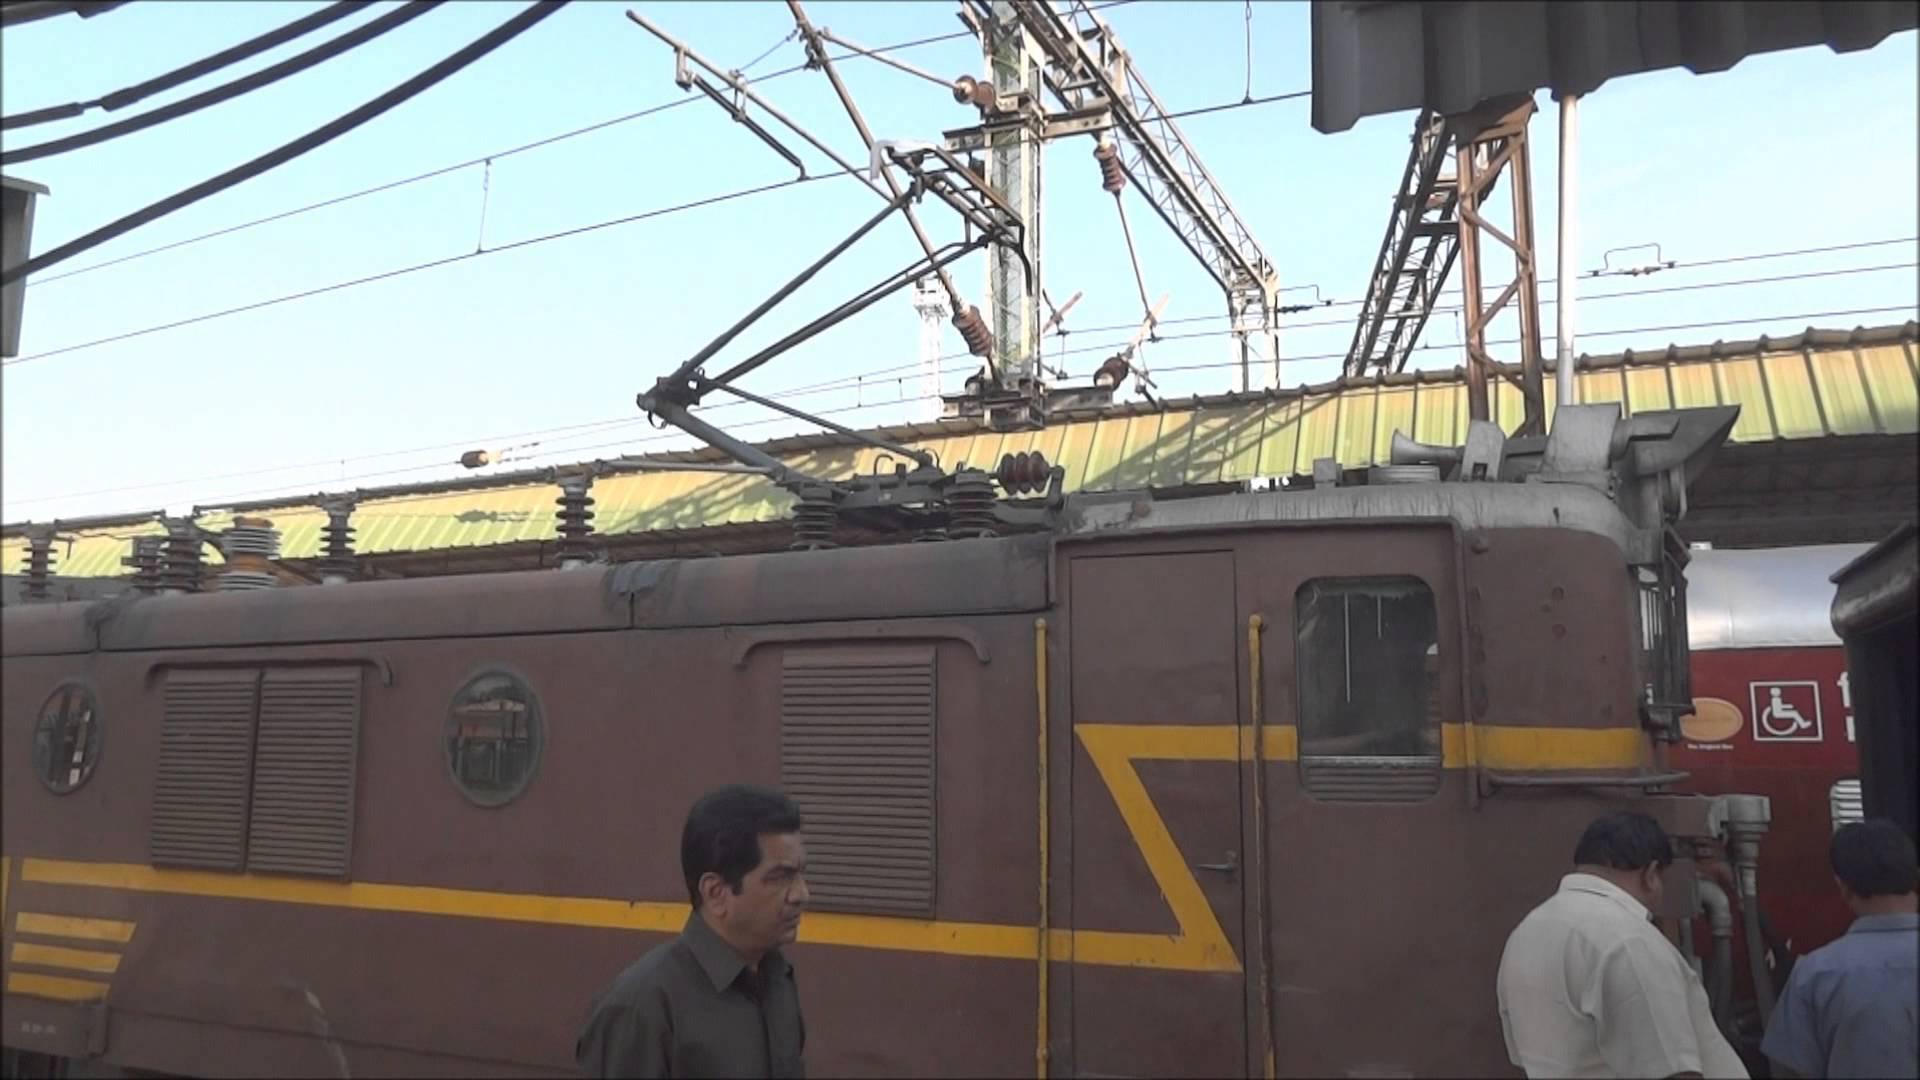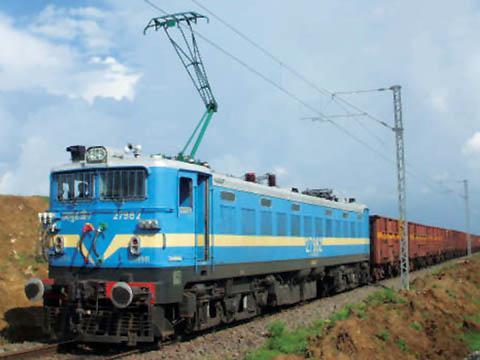The first image is the image on the left, the second image is the image on the right. Evaluate the accuracy of this statement regarding the images: "One of the trains is blue with a yellow stripe on it.". Is it true? Answer yes or no. Yes. The first image is the image on the left, the second image is the image on the right. Examine the images to the left and right. Is the description "An image shows an angled baby-blue train with a yellow stripe, and above the train is a hinged metal contraption." accurate? Answer yes or no. Yes. 